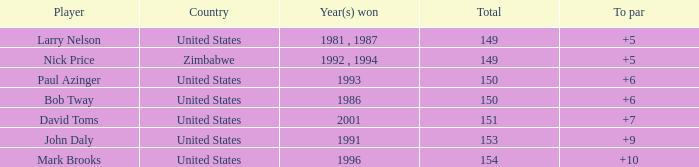What is the total for 1986 with a to par higher than 6? 0.0. 